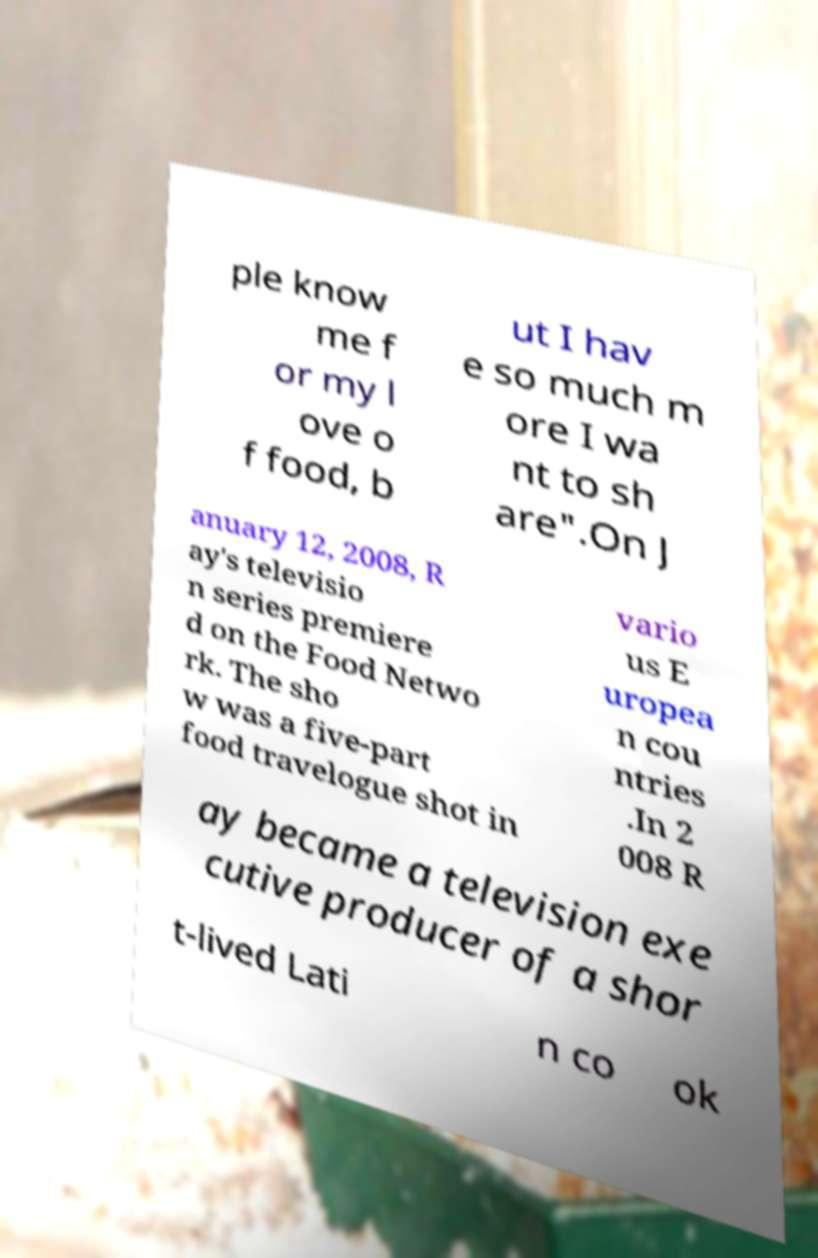Please read and relay the text visible in this image. What does it say? ple know me f or my l ove o f food, b ut I hav e so much m ore I wa nt to sh are".On J anuary 12, 2008, R ay's televisio n series premiere d on the Food Netwo rk. The sho w was a five-part food travelogue shot in vario us E uropea n cou ntries .In 2 008 R ay became a television exe cutive producer of a shor t-lived Lati n co ok 